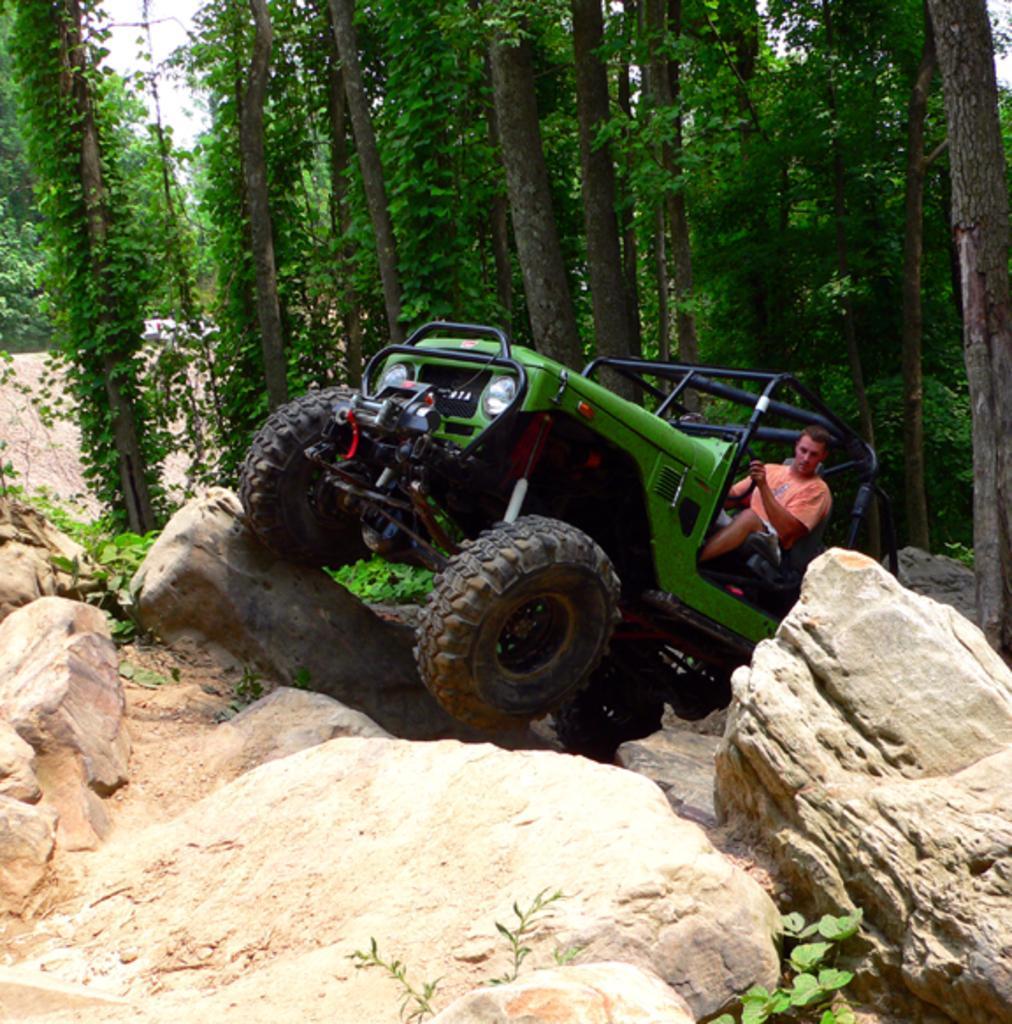Can you describe this image briefly? In this picture we can see a man is seated in the jeep, and we can find few rocks, plants and trees. 